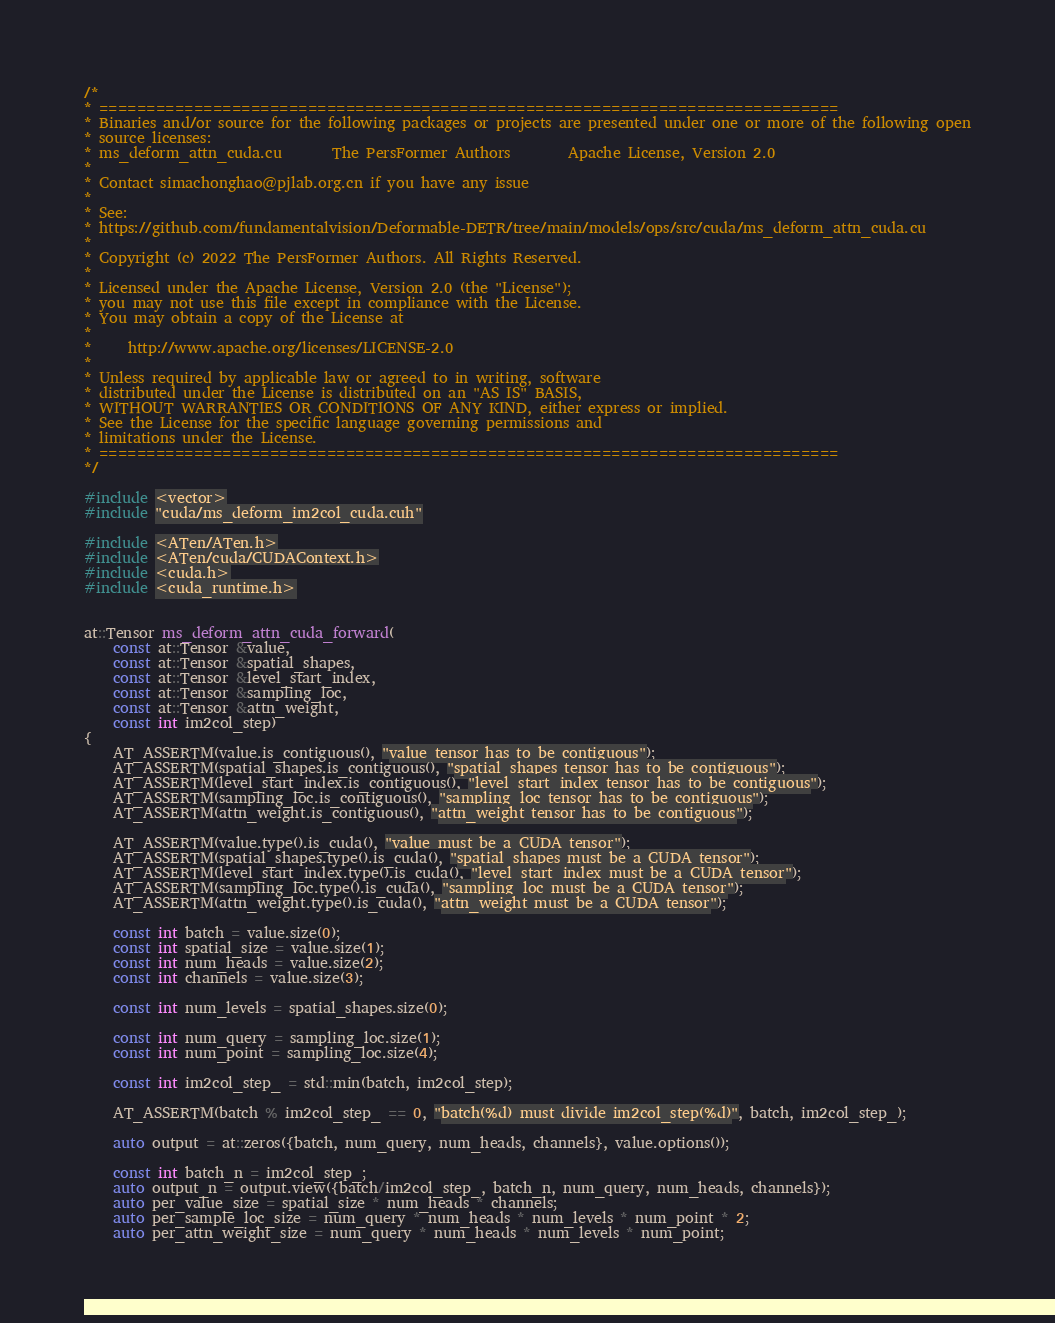<code> <loc_0><loc_0><loc_500><loc_500><_Cuda_>/*
* ==============================================================================
* Binaries and/or source for the following packages or projects are presented under one or more of the following open
* source licenses:
* ms_deform_attn_cuda.cu       The PersFormer Authors        Apache License, Version 2.0
*
* Contact simachonghao@pjlab.org.cn if you have any issue
* 
* See:
* https://github.com/fundamentalvision/Deformable-DETR/tree/main/models/ops/src/cuda/ms_deform_attn_cuda.cu
*
* Copyright (c) 2022 The PersFormer Authors. All Rights Reserved.
*
* Licensed under the Apache License, Version 2.0 (the "License");
* you may not use this file except in compliance with the License.
* You may obtain a copy of the License at
*
*     http://www.apache.org/licenses/LICENSE-2.0
*
* Unless required by applicable law or agreed to in writing, software
* distributed under the License is distributed on an "AS IS" BASIS,
* WITHOUT WARRANTIES OR CONDITIONS OF ANY KIND, either express or implied.
* See the License for the specific language governing permissions and
* limitations under the License.
* ==============================================================================
*/

#include <vector>
#include "cuda/ms_deform_im2col_cuda.cuh"

#include <ATen/ATen.h>
#include <ATen/cuda/CUDAContext.h>
#include <cuda.h>
#include <cuda_runtime.h>


at::Tensor ms_deform_attn_cuda_forward(
    const at::Tensor &value, 
    const at::Tensor &spatial_shapes,
    const at::Tensor &level_start_index,
    const at::Tensor &sampling_loc,
    const at::Tensor &attn_weight,
    const int im2col_step)
{
    AT_ASSERTM(value.is_contiguous(), "value tensor has to be contiguous");
    AT_ASSERTM(spatial_shapes.is_contiguous(), "spatial_shapes tensor has to be contiguous");
    AT_ASSERTM(level_start_index.is_contiguous(), "level_start_index tensor has to be contiguous");
    AT_ASSERTM(sampling_loc.is_contiguous(), "sampling_loc tensor has to be contiguous");
    AT_ASSERTM(attn_weight.is_contiguous(), "attn_weight tensor has to be contiguous");

    AT_ASSERTM(value.type().is_cuda(), "value must be a CUDA tensor");
    AT_ASSERTM(spatial_shapes.type().is_cuda(), "spatial_shapes must be a CUDA tensor");
    AT_ASSERTM(level_start_index.type().is_cuda(), "level_start_index must be a CUDA tensor");
    AT_ASSERTM(sampling_loc.type().is_cuda(), "sampling_loc must be a CUDA tensor");
    AT_ASSERTM(attn_weight.type().is_cuda(), "attn_weight must be a CUDA tensor");

    const int batch = value.size(0);
    const int spatial_size = value.size(1);
    const int num_heads = value.size(2);
    const int channels = value.size(3);

    const int num_levels = spatial_shapes.size(0);

    const int num_query = sampling_loc.size(1);
    const int num_point = sampling_loc.size(4);

    const int im2col_step_ = std::min(batch, im2col_step);

    AT_ASSERTM(batch % im2col_step_ == 0, "batch(%d) must divide im2col_step(%d)", batch, im2col_step_);
    
    auto output = at::zeros({batch, num_query, num_heads, channels}, value.options());

    const int batch_n = im2col_step_;
    auto output_n = output.view({batch/im2col_step_, batch_n, num_query, num_heads, channels});
    auto per_value_size = spatial_size * num_heads * channels;
    auto per_sample_loc_size = num_query * num_heads * num_levels * num_point * 2;
    auto per_attn_weight_size = num_query * num_heads * num_levels * num_point;</code> 